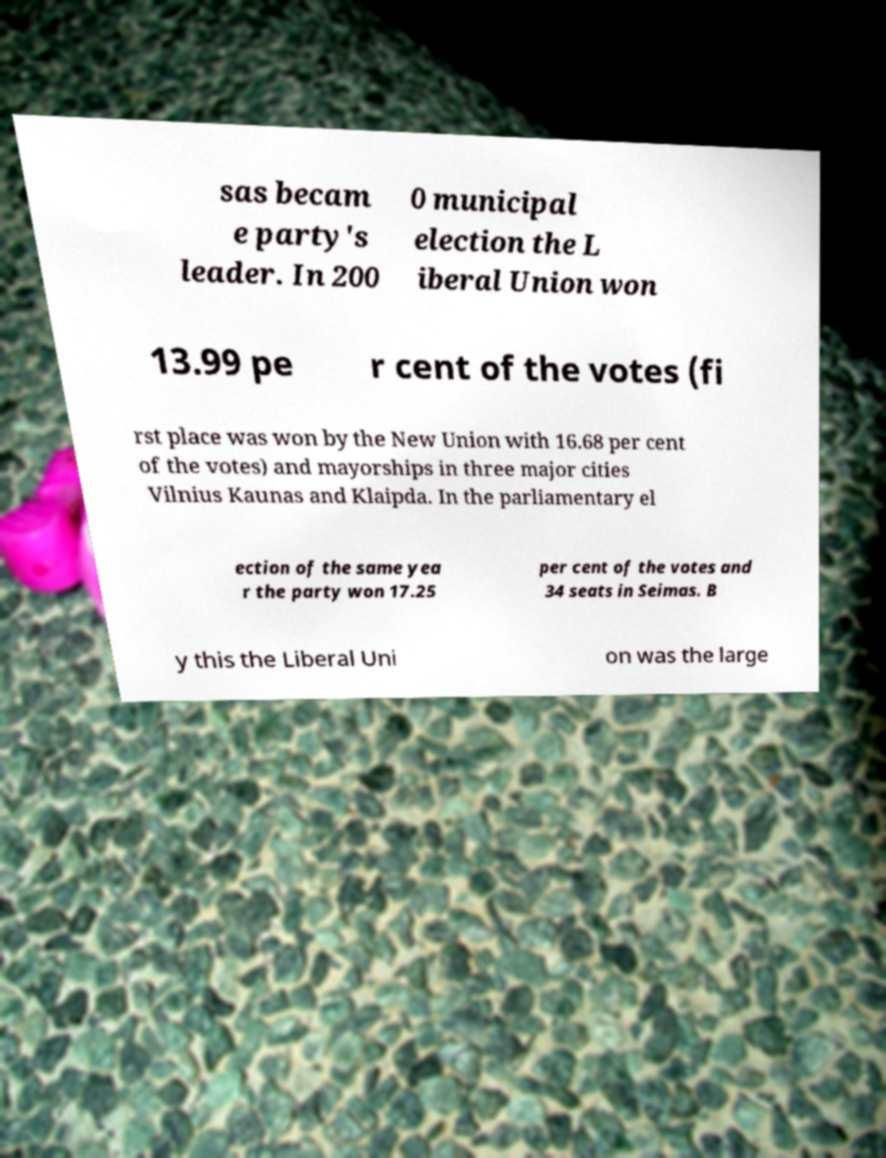What messages or text are displayed in this image? I need them in a readable, typed format. sas becam e party's leader. In 200 0 municipal election the L iberal Union won 13.99 pe r cent of the votes (fi rst place was won by the New Union with 16.68 per cent of the votes) and mayorships in three major cities Vilnius Kaunas and Klaipda. In the parliamentary el ection of the same yea r the party won 17.25 per cent of the votes and 34 seats in Seimas. B y this the Liberal Uni on was the large 